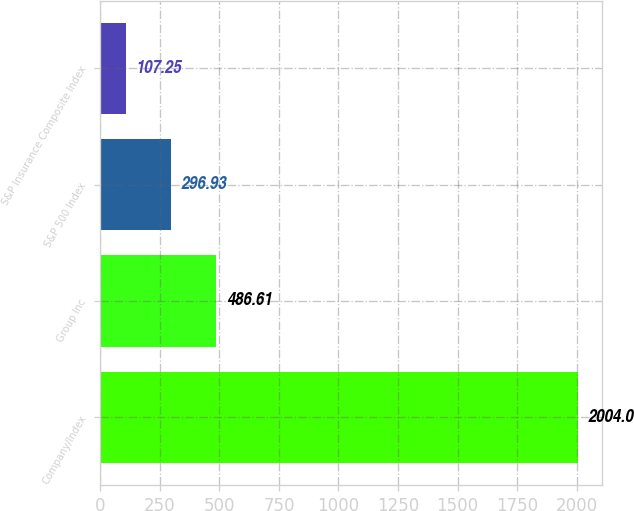Convert chart. <chart><loc_0><loc_0><loc_500><loc_500><bar_chart><fcel>Company/Index<fcel>Group Inc<fcel>S&P 500 Index<fcel>S&P Insurance Composite Index<nl><fcel>2004<fcel>486.61<fcel>296.93<fcel>107.25<nl></chart> 